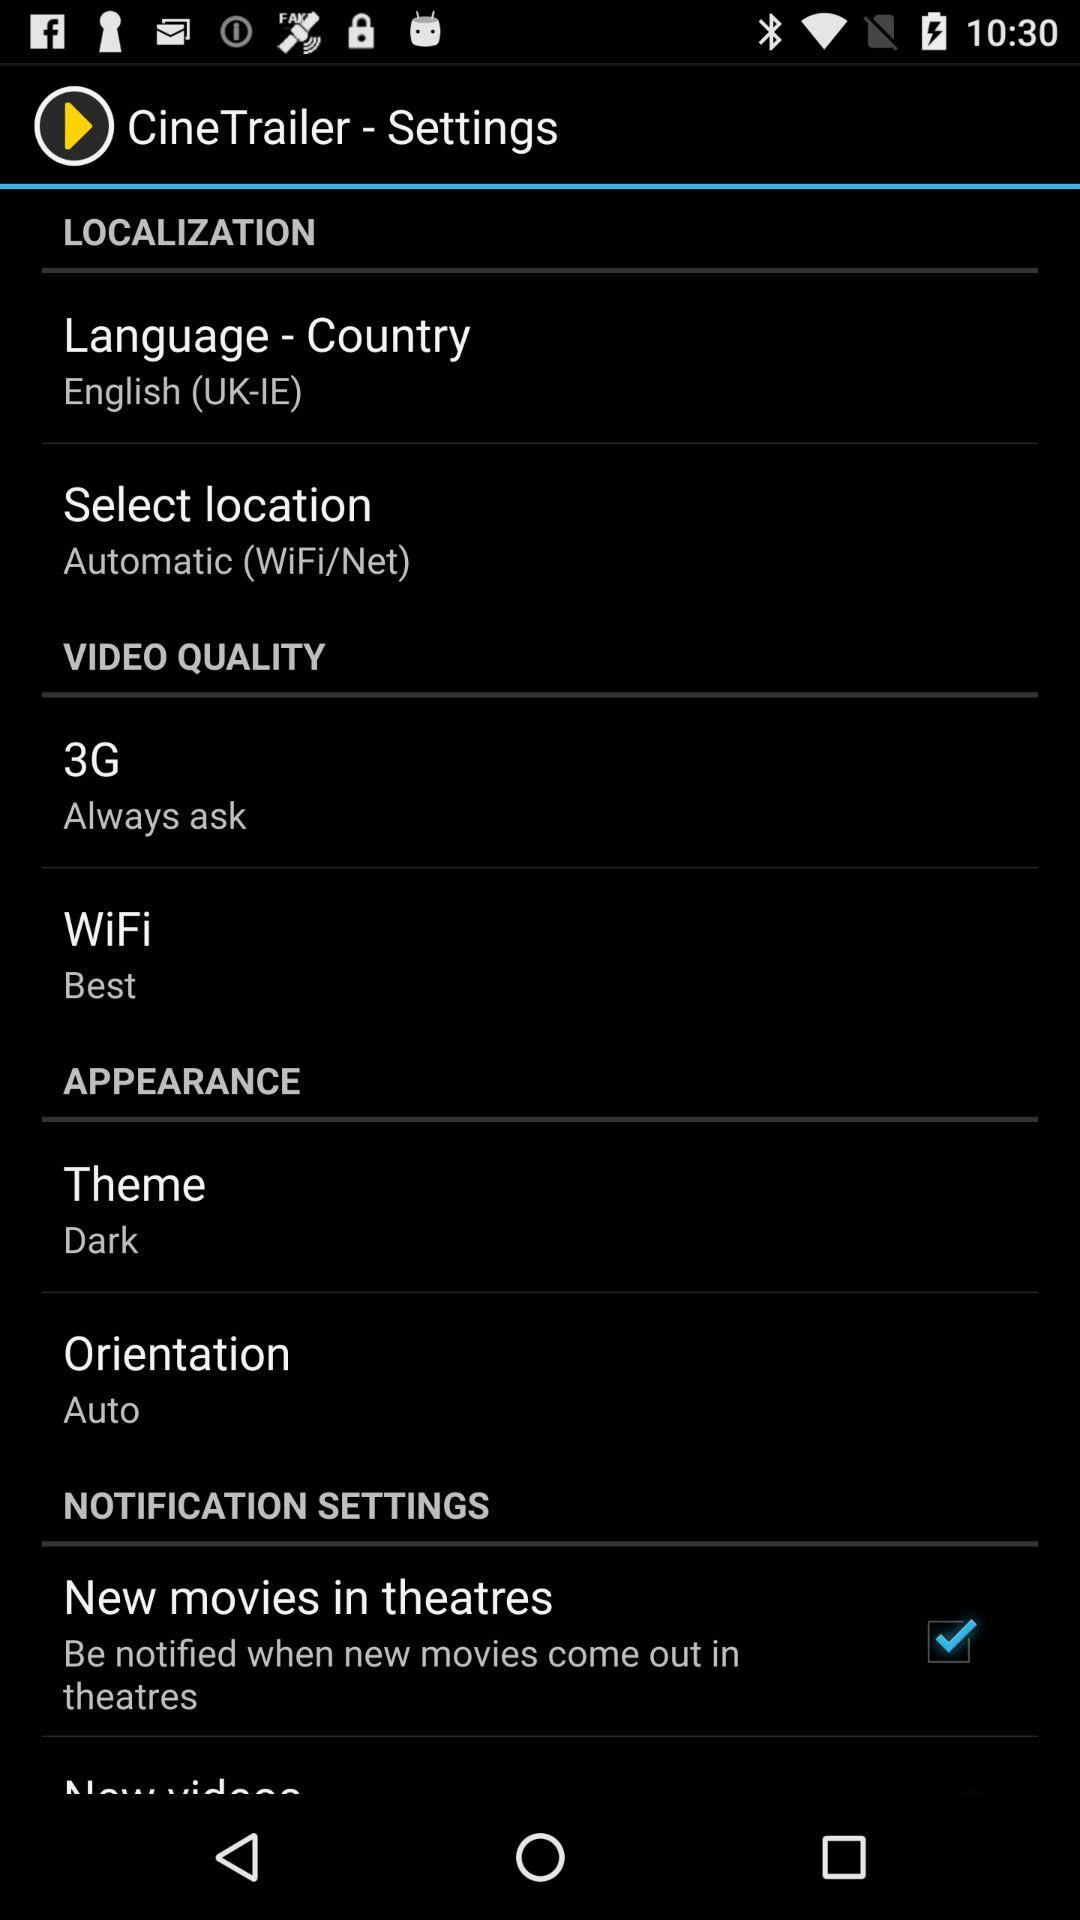What is the application name? The application name is "CineTrailer". 